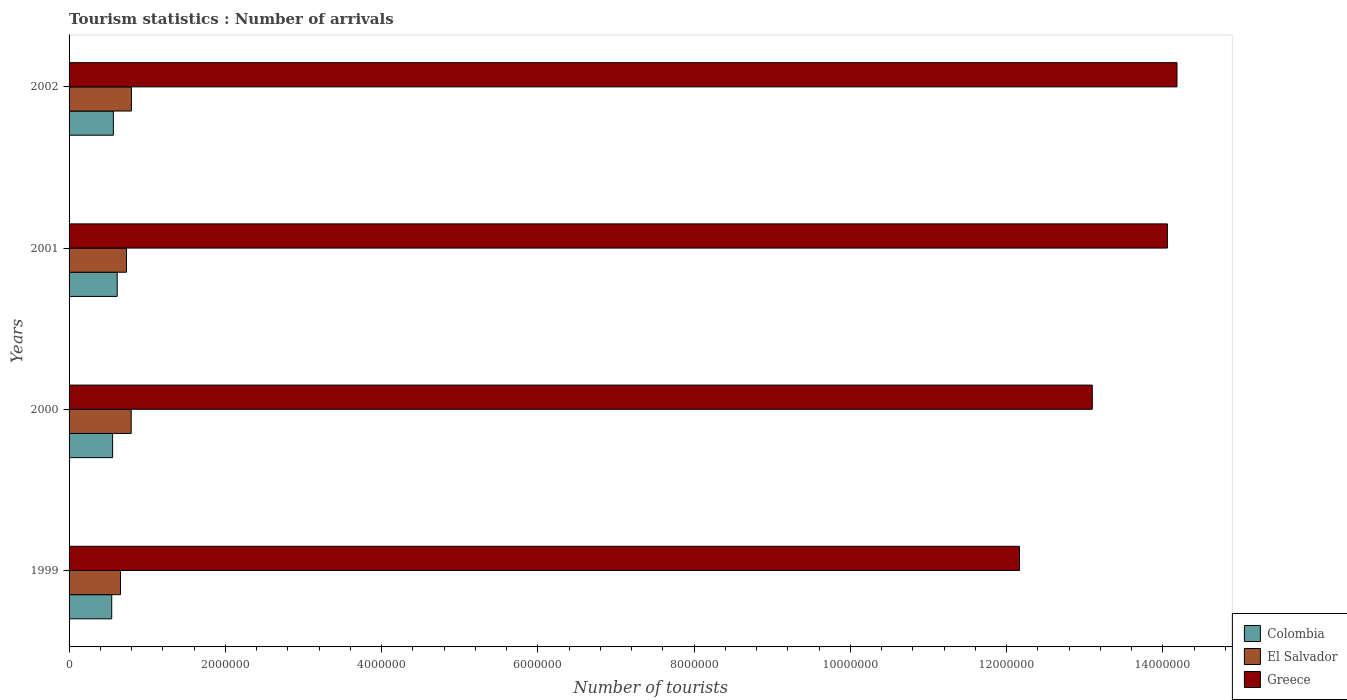How many groups of bars are there?
Your response must be concise. 4. Are the number of bars per tick equal to the number of legend labels?
Give a very brief answer. Yes. Are the number of bars on each tick of the Y-axis equal?
Offer a terse response. Yes. What is the label of the 3rd group of bars from the top?
Offer a very short reply. 2000. In how many cases, is the number of bars for a given year not equal to the number of legend labels?
Ensure brevity in your answer.  0. What is the number of tourist arrivals in Colombia in 2001?
Ensure brevity in your answer.  6.16e+05. Across all years, what is the maximum number of tourist arrivals in Greece?
Your response must be concise. 1.42e+07. Across all years, what is the minimum number of tourist arrivals in Greece?
Ensure brevity in your answer.  1.22e+07. What is the total number of tourist arrivals in Greece in the graph?
Ensure brevity in your answer.  5.35e+07. What is the difference between the number of tourist arrivals in El Salvador in 1999 and that in 2001?
Your answer should be compact. -7.70e+04. What is the difference between the number of tourist arrivals in El Salvador in 2000 and the number of tourist arrivals in Colombia in 2002?
Give a very brief answer. 2.28e+05. What is the average number of tourist arrivals in Greece per year?
Your answer should be compact. 1.34e+07. In the year 1999, what is the difference between the number of tourist arrivals in Colombia and number of tourist arrivals in El Salvador?
Ensure brevity in your answer.  -1.12e+05. What is the ratio of the number of tourist arrivals in Greece in 1999 to that in 2001?
Offer a terse response. 0.87. Is the number of tourist arrivals in Greece in 2000 less than that in 2002?
Make the answer very short. Yes. Is the difference between the number of tourist arrivals in Colombia in 2001 and 2002 greater than the difference between the number of tourist arrivals in El Salvador in 2001 and 2002?
Offer a very short reply. Yes. What is the difference between the highest and the second highest number of tourist arrivals in Colombia?
Give a very brief answer. 4.90e+04. What is the difference between the highest and the lowest number of tourist arrivals in El Salvador?
Your answer should be very brief. 1.40e+05. Is the sum of the number of tourist arrivals in Colombia in 2001 and 2002 greater than the maximum number of tourist arrivals in El Salvador across all years?
Provide a short and direct response. Yes. What does the 2nd bar from the top in 2000 represents?
Your answer should be very brief. El Salvador. What does the 2nd bar from the bottom in 2002 represents?
Offer a terse response. El Salvador. Is it the case that in every year, the sum of the number of tourist arrivals in Colombia and number of tourist arrivals in Greece is greater than the number of tourist arrivals in El Salvador?
Offer a terse response. Yes. How many bars are there?
Your answer should be very brief. 12. How many years are there in the graph?
Offer a very short reply. 4. What is the difference between two consecutive major ticks on the X-axis?
Offer a very short reply. 2.00e+06. Are the values on the major ticks of X-axis written in scientific E-notation?
Your answer should be compact. No. Does the graph contain any zero values?
Ensure brevity in your answer.  No. Does the graph contain grids?
Keep it short and to the point. No. What is the title of the graph?
Make the answer very short. Tourism statistics : Number of arrivals. Does "Nicaragua" appear as one of the legend labels in the graph?
Give a very brief answer. No. What is the label or title of the X-axis?
Give a very brief answer. Number of tourists. What is the Number of tourists in Colombia in 1999?
Make the answer very short. 5.46e+05. What is the Number of tourists in El Salvador in 1999?
Your response must be concise. 6.58e+05. What is the Number of tourists of Greece in 1999?
Offer a terse response. 1.22e+07. What is the Number of tourists in Colombia in 2000?
Offer a terse response. 5.57e+05. What is the Number of tourists in El Salvador in 2000?
Your answer should be compact. 7.95e+05. What is the Number of tourists in Greece in 2000?
Offer a terse response. 1.31e+07. What is the Number of tourists of Colombia in 2001?
Your response must be concise. 6.16e+05. What is the Number of tourists in El Salvador in 2001?
Your answer should be compact. 7.35e+05. What is the Number of tourists of Greece in 2001?
Offer a very short reply. 1.41e+07. What is the Number of tourists of Colombia in 2002?
Provide a succinct answer. 5.67e+05. What is the Number of tourists of El Salvador in 2002?
Ensure brevity in your answer.  7.98e+05. What is the Number of tourists in Greece in 2002?
Your response must be concise. 1.42e+07. Across all years, what is the maximum Number of tourists in Colombia?
Your answer should be very brief. 6.16e+05. Across all years, what is the maximum Number of tourists of El Salvador?
Keep it short and to the point. 7.98e+05. Across all years, what is the maximum Number of tourists in Greece?
Keep it short and to the point. 1.42e+07. Across all years, what is the minimum Number of tourists in Colombia?
Offer a terse response. 5.46e+05. Across all years, what is the minimum Number of tourists of El Salvador?
Offer a terse response. 6.58e+05. Across all years, what is the minimum Number of tourists in Greece?
Offer a terse response. 1.22e+07. What is the total Number of tourists of Colombia in the graph?
Make the answer very short. 2.29e+06. What is the total Number of tourists in El Salvador in the graph?
Your answer should be compact. 2.99e+06. What is the total Number of tourists of Greece in the graph?
Ensure brevity in your answer.  5.35e+07. What is the difference between the Number of tourists of Colombia in 1999 and that in 2000?
Provide a succinct answer. -1.10e+04. What is the difference between the Number of tourists in El Salvador in 1999 and that in 2000?
Provide a short and direct response. -1.37e+05. What is the difference between the Number of tourists of Greece in 1999 and that in 2000?
Offer a terse response. -9.32e+05. What is the difference between the Number of tourists of El Salvador in 1999 and that in 2001?
Offer a terse response. -7.70e+04. What is the difference between the Number of tourists in Greece in 1999 and that in 2001?
Offer a terse response. -1.89e+06. What is the difference between the Number of tourists of Colombia in 1999 and that in 2002?
Your answer should be very brief. -2.10e+04. What is the difference between the Number of tourists in El Salvador in 1999 and that in 2002?
Offer a very short reply. -1.40e+05. What is the difference between the Number of tourists in Greece in 1999 and that in 2002?
Offer a terse response. -2.02e+06. What is the difference between the Number of tourists in Colombia in 2000 and that in 2001?
Offer a terse response. -5.90e+04. What is the difference between the Number of tourists of El Salvador in 2000 and that in 2001?
Your answer should be compact. 6.00e+04. What is the difference between the Number of tourists of Greece in 2000 and that in 2001?
Offer a very short reply. -9.61e+05. What is the difference between the Number of tourists in Colombia in 2000 and that in 2002?
Provide a succinct answer. -10000. What is the difference between the Number of tourists in El Salvador in 2000 and that in 2002?
Ensure brevity in your answer.  -3000. What is the difference between the Number of tourists of Greece in 2000 and that in 2002?
Ensure brevity in your answer.  -1.08e+06. What is the difference between the Number of tourists in Colombia in 2001 and that in 2002?
Your response must be concise. 4.90e+04. What is the difference between the Number of tourists of El Salvador in 2001 and that in 2002?
Give a very brief answer. -6.30e+04. What is the difference between the Number of tourists in Greece in 2001 and that in 2002?
Keep it short and to the point. -1.23e+05. What is the difference between the Number of tourists of Colombia in 1999 and the Number of tourists of El Salvador in 2000?
Your answer should be compact. -2.49e+05. What is the difference between the Number of tourists in Colombia in 1999 and the Number of tourists in Greece in 2000?
Offer a very short reply. -1.26e+07. What is the difference between the Number of tourists in El Salvador in 1999 and the Number of tourists in Greece in 2000?
Provide a succinct answer. -1.24e+07. What is the difference between the Number of tourists in Colombia in 1999 and the Number of tourists in El Salvador in 2001?
Ensure brevity in your answer.  -1.89e+05. What is the difference between the Number of tourists of Colombia in 1999 and the Number of tourists of Greece in 2001?
Give a very brief answer. -1.35e+07. What is the difference between the Number of tourists of El Salvador in 1999 and the Number of tourists of Greece in 2001?
Make the answer very short. -1.34e+07. What is the difference between the Number of tourists of Colombia in 1999 and the Number of tourists of El Salvador in 2002?
Provide a succinct answer. -2.52e+05. What is the difference between the Number of tourists in Colombia in 1999 and the Number of tourists in Greece in 2002?
Your response must be concise. -1.36e+07. What is the difference between the Number of tourists of El Salvador in 1999 and the Number of tourists of Greece in 2002?
Give a very brief answer. -1.35e+07. What is the difference between the Number of tourists of Colombia in 2000 and the Number of tourists of El Salvador in 2001?
Offer a terse response. -1.78e+05. What is the difference between the Number of tourists of Colombia in 2000 and the Number of tourists of Greece in 2001?
Ensure brevity in your answer.  -1.35e+07. What is the difference between the Number of tourists of El Salvador in 2000 and the Number of tourists of Greece in 2001?
Offer a terse response. -1.33e+07. What is the difference between the Number of tourists of Colombia in 2000 and the Number of tourists of El Salvador in 2002?
Provide a short and direct response. -2.41e+05. What is the difference between the Number of tourists in Colombia in 2000 and the Number of tourists in Greece in 2002?
Keep it short and to the point. -1.36e+07. What is the difference between the Number of tourists of El Salvador in 2000 and the Number of tourists of Greece in 2002?
Provide a short and direct response. -1.34e+07. What is the difference between the Number of tourists of Colombia in 2001 and the Number of tourists of El Salvador in 2002?
Your answer should be very brief. -1.82e+05. What is the difference between the Number of tourists in Colombia in 2001 and the Number of tourists in Greece in 2002?
Provide a short and direct response. -1.36e+07. What is the difference between the Number of tourists of El Salvador in 2001 and the Number of tourists of Greece in 2002?
Give a very brief answer. -1.34e+07. What is the average Number of tourists in Colombia per year?
Offer a terse response. 5.72e+05. What is the average Number of tourists of El Salvador per year?
Your response must be concise. 7.46e+05. What is the average Number of tourists of Greece per year?
Give a very brief answer. 1.34e+07. In the year 1999, what is the difference between the Number of tourists in Colombia and Number of tourists in El Salvador?
Offer a very short reply. -1.12e+05. In the year 1999, what is the difference between the Number of tourists of Colombia and Number of tourists of Greece?
Ensure brevity in your answer.  -1.16e+07. In the year 1999, what is the difference between the Number of tourists of El Salvador and Number of tourists of Greece?
Provide a short and direct response. -1.15e+07. In the year 2000, what is the difference between the Number of tourists of Colombia and Number of tourists of El Salvador?
Offer a terse response. -2.38e+05. In the year 2000, what is the difference between the Number of tourists of Colombia and Number of tourists of Greece?
Provide a succinct answer. -1.25e+07. In the year 2000, what is the difference between the Number of tourists in El Salvador and Number of tourists in Greece?
Your answer should be compact. -1.23e+07. In the year 2001, what is the difference between the Number of tourists of Colombia and Number of tourists of El Salvador?
Your answer should be compact. -1.19e+05. In the year 2001, what is the difference between the Number of tourists in Colombia and Number of tourists in Greece?
Provide a succinct answer. -1.34e+07. In the year 2001, what is the difference between the Number of tourists in El Salvador and Number of tourists in Greece?
Give a very brief answer. -1.33e+07. In the year 2002, what is the difference between the Number of tourists in Colombia and Number of tourists in El Salvador?
Offer a terse response. -2.31e+05. In the year 2002, what is the difference between the Number of tourists of Colombia and Number of tourists of Greece?
Provide a short and direct response. -1.36e+07. In the year 2002, what is the difference between the Number of tourists of El Salvador and Number of tourists of Greece?
Provide a short and direct response. -1.34e+07. What is the ratio of the Number of tourists of Colombia in 1999 to that in 2000?
Keep it short and to the point. 0.98. What is the ratio of the Number of tourists of El Salvador in 1999 to that in 2000?
Make the answer very short. 0.83. What is the ratio of the Number of tourists of Greece in 1999 to that in 2000?
Provide a succinct answer. 0.93. What is the ratio of the Number of tourists in Colombia in 1999 to that in 2001?
Keep it short and to the point. 0.89. What is the ratio of the Number of tourists of El Salvador in 1999 to that in 2001?
Your response must be concise. 0.9. What is the ratio of the Number of tourists of Greece in 1999 to that in 2001?
Provide a short and direct response. 0.87. What is the ratio of the Number of tourists of Colombia in 1999 to that in 2002?
Provide a short and direct response. 0.96. What is the ratio of the Number of tourists in El Salvador in 1999 to that in 2002?
Make the answer very short. 0.82. What is the ratio of the Number of tourists of Greece in 1999 to that in 2002?
Provide a short and direct response. 0.86. What is the ratio of the Number of tourists in Colombia in 2000 to that in 2001?
Offer a terse response. 0.9. What is the ratio of the Number of tourists in El Salvador in 2000 to that in 2001?
Make the answer very short. 1.08. What is the ratio of the Number of tourists in Greece in 2000 to that in 2001?
Your answer should be compact. 0.93. What is the ratio of the Number of tourists of Colombia in 2000 to that in 2002?
Your answer should be very brief. 0.98. What is the ratio of the Number of tourists in Greece in 2000 to that in 2002?
Offer a terse response. 0.92. What is the ratio of the Number of tourists in Colombia in 2001 to that in 2002?
Your answer should be compact. 1.09. What is the ratio of the Number of tourists of El Salvador in 2001 to that in 2002?
Offer a very short reply. 0.92. What is the difference between the highest and the second highest Number of tourists in Colombia?
Provide a succinct answer. 4.90e+04. What is the difference between the highest and the second highest Number of tourists in El Salvador?
Provide a succinct answer. 3000. What is the difference between the highest and the second highest Number of tourists of Greece?
Provide a succinct answer. 1.23e+05. What is the difference between the highest and the lowest Number of tourists of Colombia?
Make the answer very short. 7.00e+04. What is the difference between the highest and the lowest Number of tourists in El Salvador?
Give a very brief answer. 1.40e+05. What is the difference between the highest and the lowest Number of tourists in Greece?
Make the answer very short. 2.02e+06. 